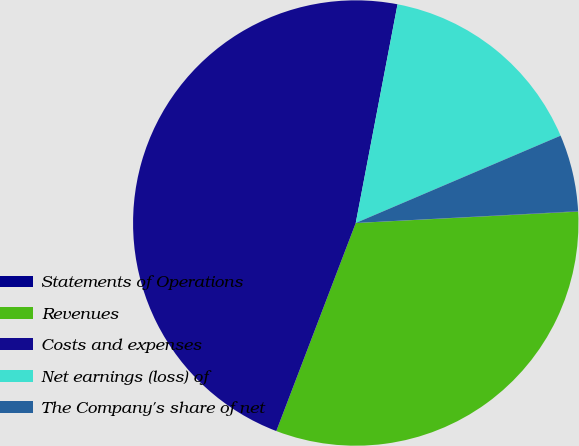<chart> <loc_0><loc_0><loc_500><loc_500><pie_chart><fcel>Statements of Operations<fcel>Revenues<fcel>Costs and expenses<fcel>Net earnings (loss) of<fcel>The Company's share of net<nl><fcel>0.03%<fcel>31.62%<fcel>47.2%<fcel>15.58%<fcel>5.57%<nl></chart> 